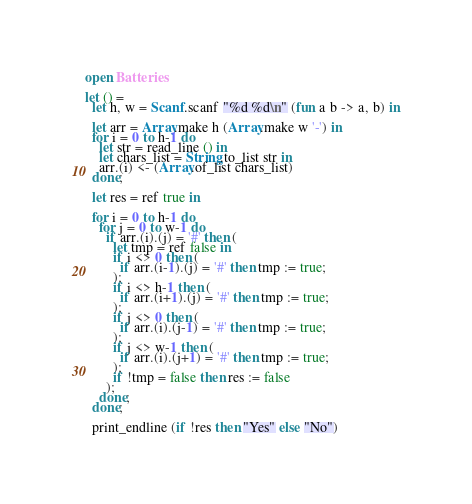<code> <loc_0><loc_0><loc_500><loc_500><_OCaml_>open Batteries

let () =
  let h, w = Scanf.scanf "%d %d\n" (fun a b -> a, b) in

  let arr = Array.make h (Array.make w '-') in
  for i = 0 to h-1 do
    let str = read_line () in
    let chars_list = String.to_list str in
    arr.(i) <- (Array.of_list chars_list)
  done;

  let res = ref true in

  for i = 0 to h-1 do
    for j = 0 to w-1 do
      if arr.(i).(j) = '#' then (
        let tmp = ref false in
        if i <> 0 then (
          if arr.(i-1).(j) = '#' then tmp := true;
        );
        if i <> h-1 then (
          if arr.(i+1).(j) = '#' then tmp := true;
        );
        if j <> 0 then (
          if arr.(i).(j-1) = '#' then tmp := true;
        );
        if j <> w-1 then (
          if arr.(i).(j+1) = '#' then tmp := true;
        );
        if !tmp = false then res := false
      );
    done;
  done;

  print_endline (if !res then "Yes" else "No")
</code> 